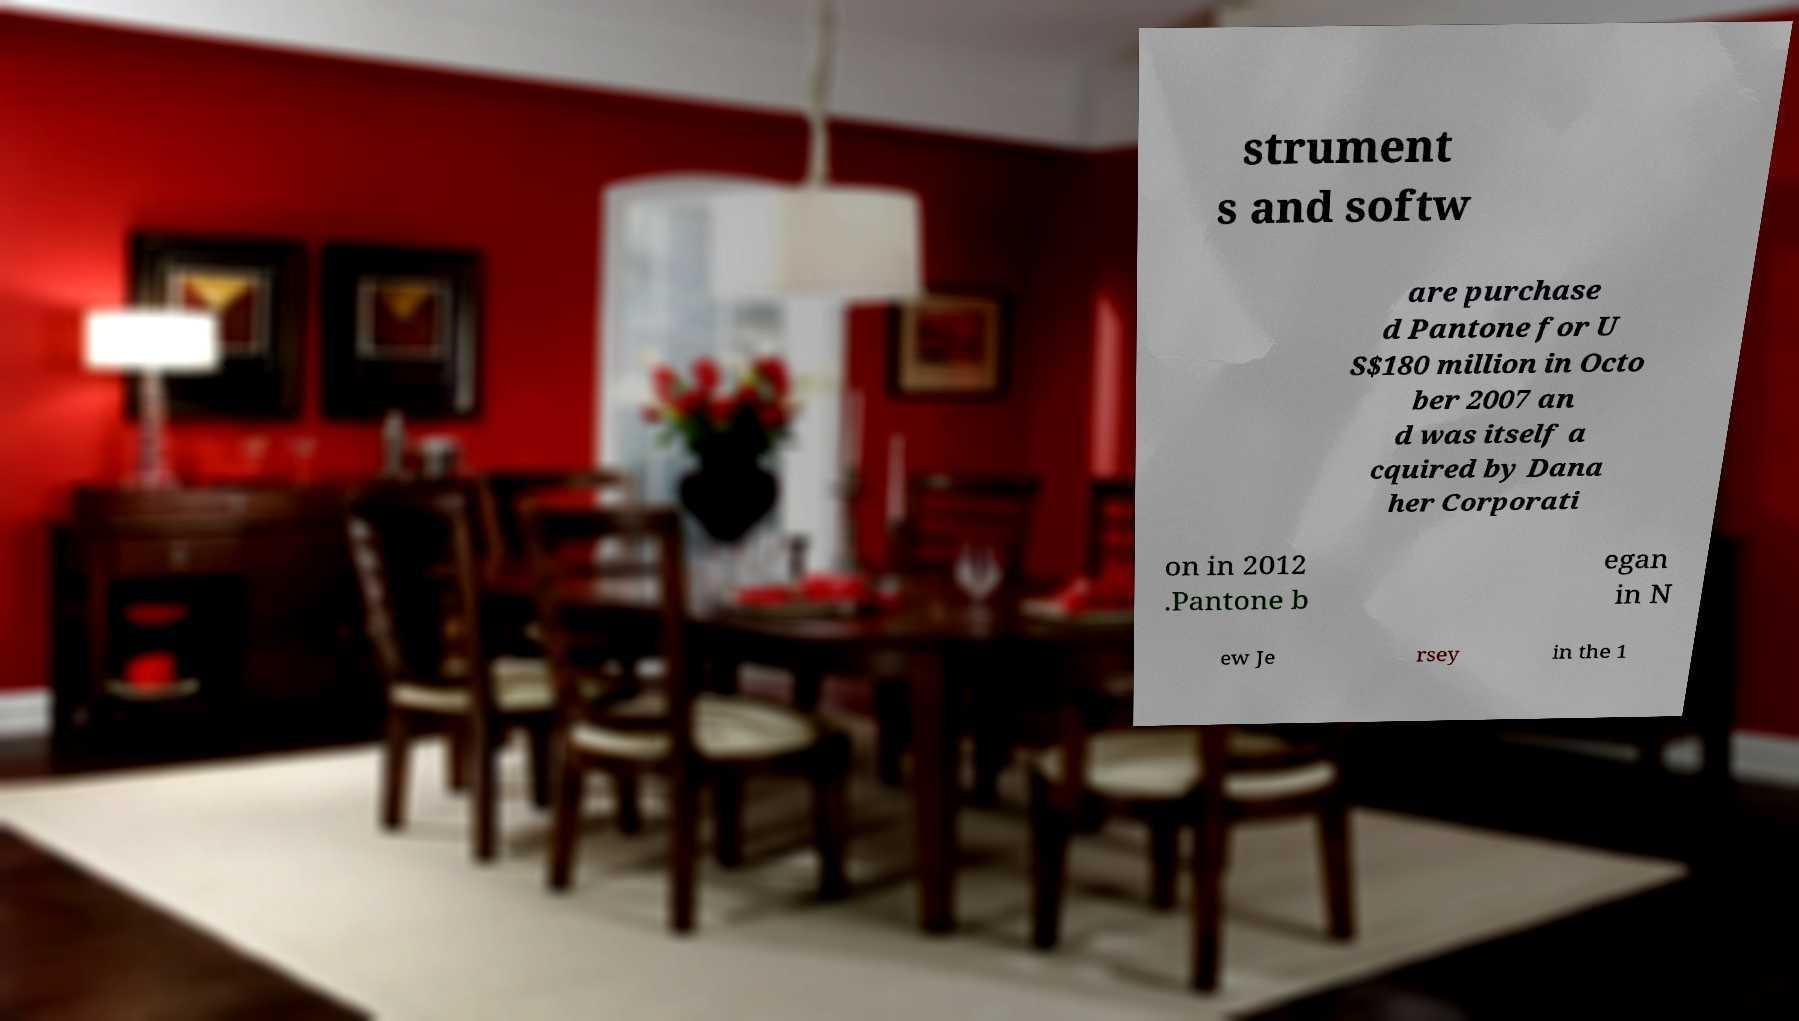Can you read and provide the text displayed in the image?This photo seems to have some interesting text. Can you extract and type it out for me? strument s and softw are purchase d Pantone for U S$180 million in Octo ber 2007 an d was itself a cquired by Dana her Corporati on in 2012 .Pantone b egan in N ew Je rsey in the 1 